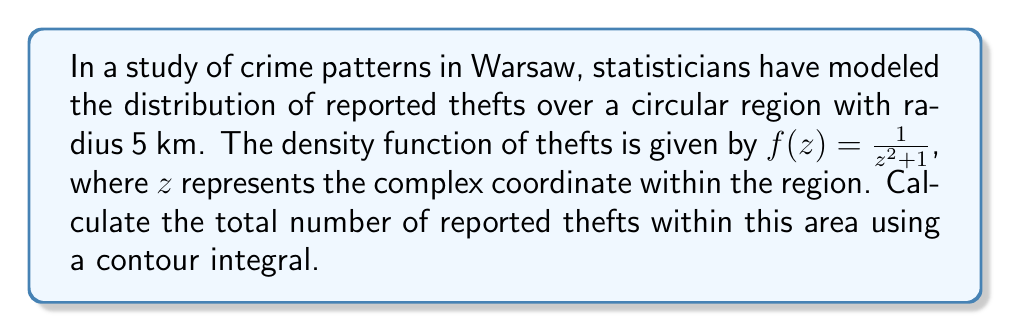Give your solution to this math problem. To solve this problem, we need to evaluate the contour integral of the given function over the circular region. Let's approach this step-by-step:

1) The total number of reported thefts is given by the integral of the density function over the entire region. In complex analysis, this is equivalent to:

   $$N = \frac{1}{2\pi i} \oint_C \frac{f(z)}{z} dz$$

   where $C$ is the circular contour with radius 5 km.

2) Substituting our density function:

   $$N = \frac{1}{2\pi i} \oint_C \frac{1}{z(z^2 + 1)} dz$$

3) This integral can be evaluated using the residue theorem. The integrand has poles at $z = 0$, $z = i$, and $z = -i$. However, only $z = 0$ and $z = i$ are within our contour.

4) Let's calculate the residues:

   At $z = 0$: $Res(f, 0) = \lim_{z \to 0} \frac{1}{z^2 + 1} = 1$

   At $z = i$: $Res(f, i) = \lim_{z \to i} \frac{z}{z(z^2 + 1)} = \frac{i}{2i} = \frac{1}{2}$

5) According to the residue theorem:

   $$N = 2\pi i \cdot \frac{1}{2\pi i} (Res(f, 0) + Res(f, i))$$

6) Substituting the residues:

   $$N = 1 + \frac{1}{2} = \frac{3}{2}$$

Therefore, the total number of reported thefts within the circular region is 1.5.
Answer: $\frac{3}{2}$ or 1.5 reported thefts 